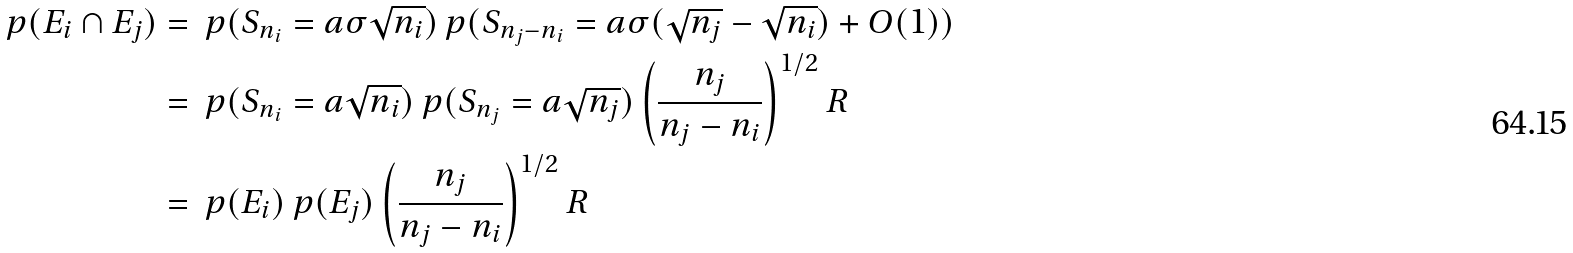<formula> <loc_0><loc_0><loc_500><loc_500>\ p ( E _ { i } \cap E _ { j } ) & = \ p ( S _ { n _ { i } } = a \sigma \sqrt { n _ { i } } ) \ p ( S _ { n _ { j } - n _ { i } } = a \sigma ( \sqrt { n _ { j } } - \sqrt { n _ { i } } ) + O ( 1 ) ) \\ & = \ p ( S _ { n _ { i } } = a \sqrt { n _ { i } } ) \ p ( S _ { n _ { j } } = a \sqrt { n _ { j } } ) \left ( \frac { n _ { j } } { n _ { j } - n _ { i } } \right ) ^ { 1 / 2 } R \\ & = \ p ( E _ { i } ) \ p ( E _ { j } ) \left ( \frac { n _ { j } } { n _ { j } - n _ { i } } \right ) ^ { 1 / 2 } R</formula> 